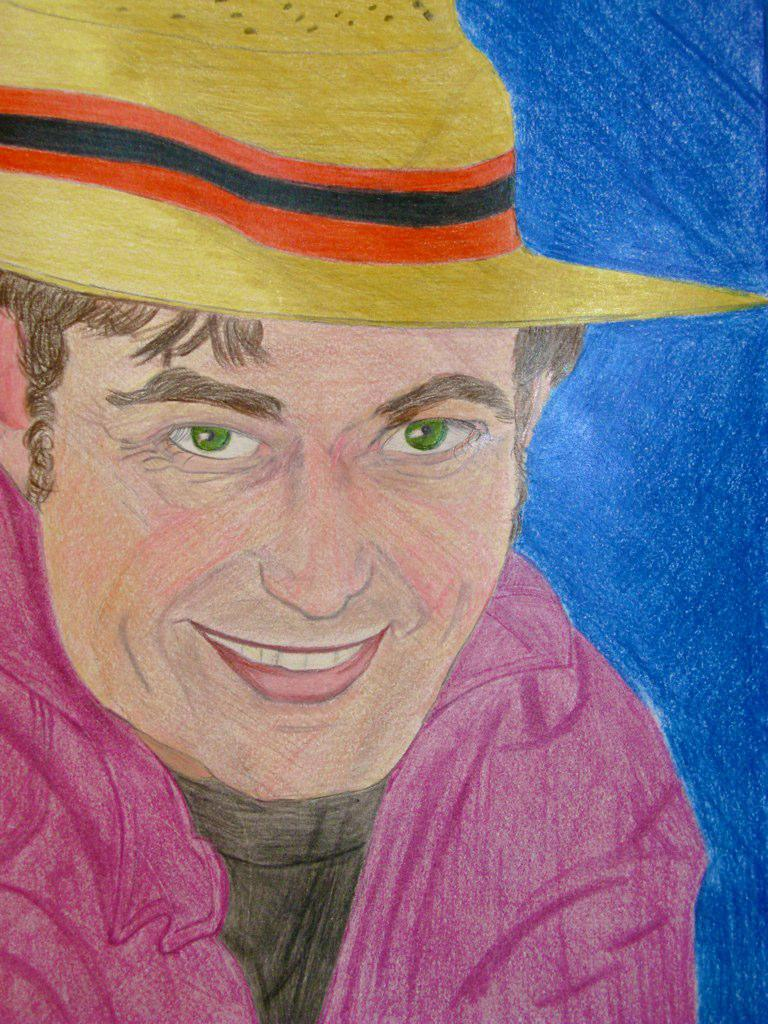What is the main subject of the image? There is a painting in the image. What is depicted in the painting? The painting depicts a man. What expression does the man have in the painting? The man is smiling in the painting. What is the man wearing in the painting? The man is wearing a cap in the painting. What type of bread is the man holding in the painting? There is no bread present in the painting; the man is depicted wearing a cap and smiling. 